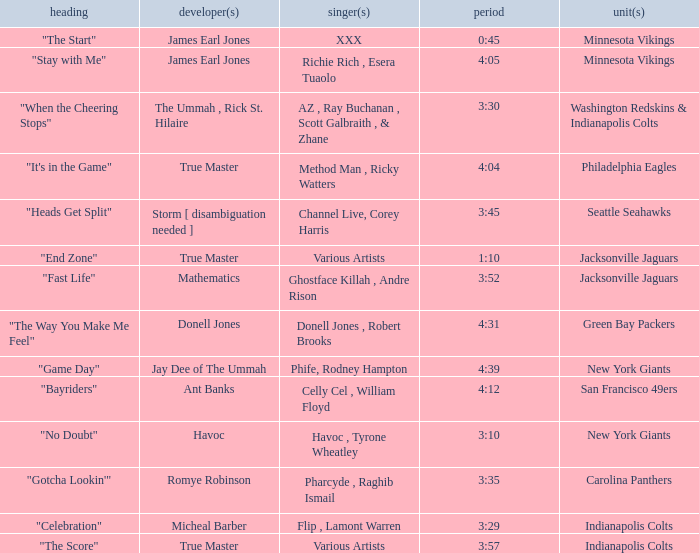Who produced "Fast Life"? Mathematics. 